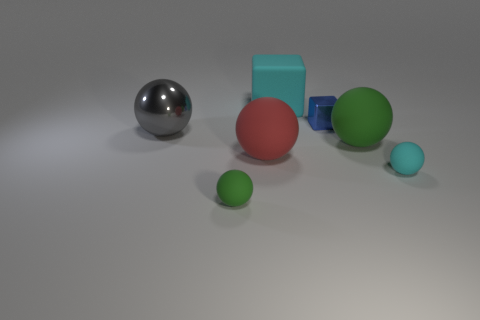Subtract all red balls. How many balls are left? 4 Subtract all large gray metal balls. How many balls are left? 4 Add 2 red things. How many objects exist? 9 Subtract all blocks. How many objects are left? 5 Add 6 small blue metallic cubes. How many small blue metallic cubes are left? 7 Add 6 tiny cyan spheres. How many tiny cyan spheres exist? 7 Subtract 0 purple blocks. How many objects are left? 7 Subtract all tiny blocks. Subtract all large red rubber cylinders. How many objects are left? 6 